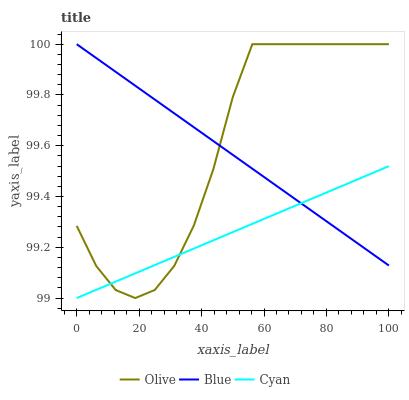Does Cyan have the minimum area under the curve?
Answer yes or no. Yes. Does Olive have the maximum area under the curve?
Answer yes or no. Yes. Does Blue have the minimum area under the curve?
Answer yes or no. No. Does Blue have the maximum area under the curve?
Answer yes or no. No. Is Blue the smoothest?
Answer yes or no. Yes. Is Olive the roughest?
Answer yes or no. Yes. Is Cyan the smoothest?
Answer yes or no. No. Is Cyan the roughest?
Answer yes or no. No. Does Cyan have the lowest value?
Answer yes or no. Yes. Does Blue have the lowest value?
Answer yes or no. No. Does Blue have the highest value?
Answer yes or no. Yes. Does Cyan have the highest value?
Answer yes or no. No. Does Olive intersect Cyan?
Answer yes or no. Yes. Is Olive less than Cyan?
Answer yes or no. No. Is Olive greater than Cyan?
Answer yes or no. No. 